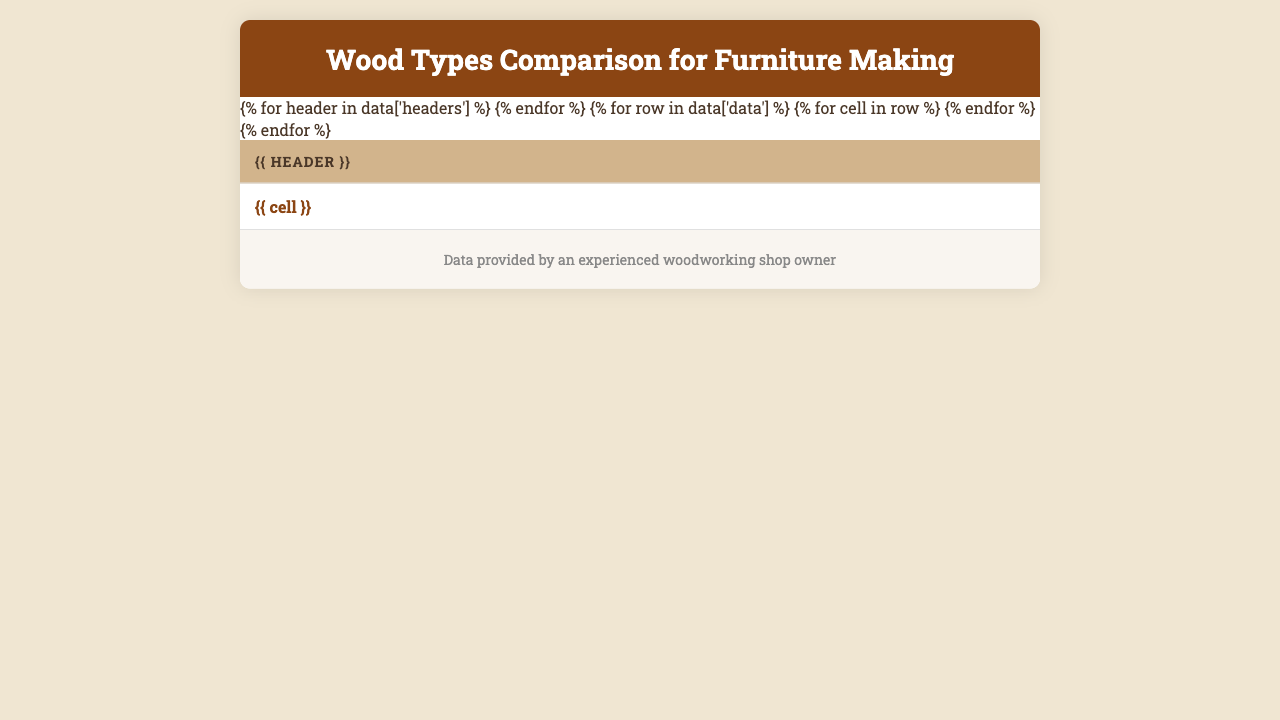What is the cost per board foot of Cherry wood? The table lists the cost per board foot for Cherry wood as $6.75.
Answer: $6.75 Which wood type has the highest Janka hardness rating? The highest Janka hardness rating in the table is for Hard Maple with a value of 1450.
Answer: Hard Maple Is Pine wood easy to work with? The table indicates that Pine has an ease of working rating of "Very Easy."
Answer: Yes What is the difference in cost between Walnut and Mahogany per board foot? Walnut costs $8.50 per board foot and Mahogany costs $9.75, so the difference is $9.75 - $8.50 = $1.25.
Answer: $1.25 Which wood types have an "Excellent" finishing quality? The woods listed with "Excellent" finishing quality are Red Oak, Cherry, Walnut, and Mahogany.
Answer: Red Oak, Cherry, Walnut, Mahogany What is the average cost per board foot of wood types that have "High" durability? First, identify the woods with "High" durability: Red Oak ($3.50), Walnut ($8.50), and Ash ($3.75). Next, sum these costs: $3.50 + $8.50 + $3.75 = $15.75. Now, divide by the number of wood types (3): $15.75 / 3 = $5.25.
Answer: $5.25 Which wood type is the easiest to work with based on the table? The table shows that Pine and Poplar both have "Very Easy" as their ease of working rating, so either can be considered the easiest.
Answer: Pine or Poplar What percentage of the wood types listed have "Moderate" durability? There are 10 wood types total, with 3 (Cherry, Birch, and Mahogany) having "Moderate" durability. To find the percentage: (3/10) * 100 = 30%.
Answer: 30% Is Hard Maple more durable than White Oak based on the table? Hard Maple is listed with "Very High" durability while White Oak is rated as "High," making Hard Maple more durable.
Answer: Yes If I want to use wood types that are easy to work with and have an excellent finishing quality for a project, which types should I choose? The woods that fit both criteria are Cherry and Walnut, as they are rated "Easy" and have "Excellent" finishing quality.
Answer: Cherry, Walnut 